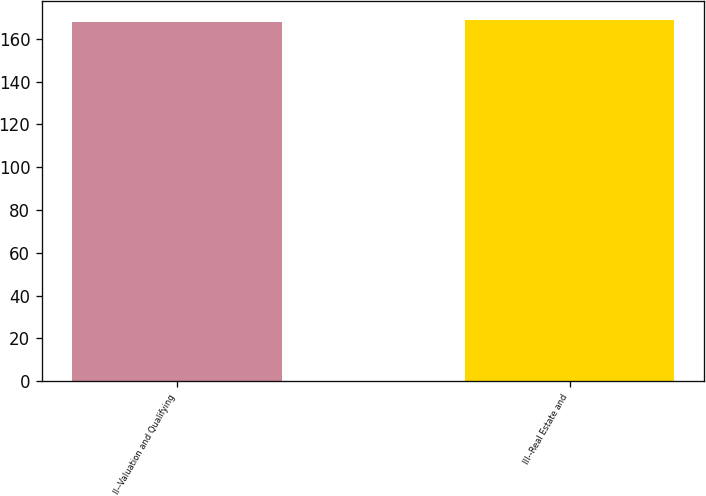Convert chart. <chart><loc_0><loc_0><loc_500><loc_500><bar_chart><fcel>II--Valuation and Qualifying<fcel>III--Real Estate and<nl><fcel>168<fcel>169<nl></chart> 